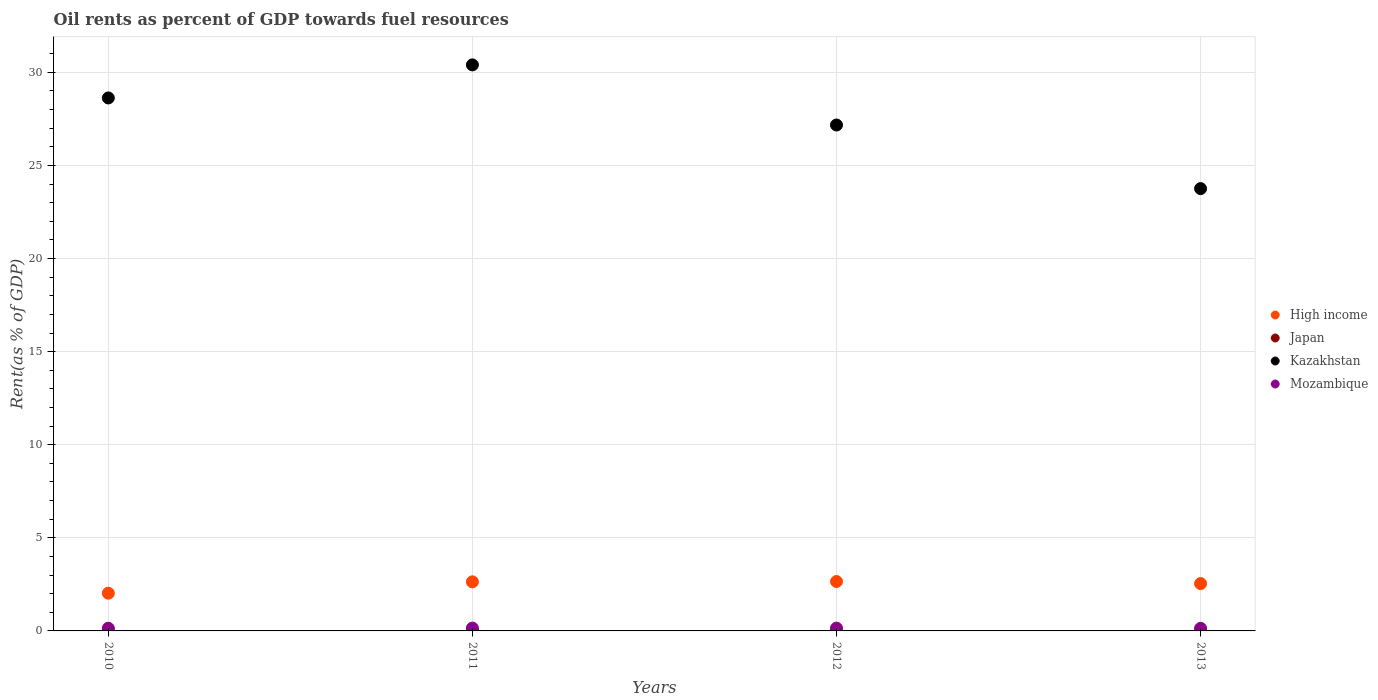Is the number of dotlines equal to the number of legend labels?
Your answer should be compact. Yes. What is the oil rent in Mozambique in 2012?
Keep it short and to the point. 0.15. Across all years, what is the maximum oil rent in Kazakhstan?
Ensure brevity in your answer.  30.4. Across all years, what is the minimum oil rent in High income?
Your response must be concise. 2.03. In which year was the oil rent in Kazakhstan minimum?
Make the answer very short. 2013. What is the total oil rent in Kazakhstan in the graph?
Your response must be concise. 109.96. What is the difference between the oil rent in Japan in 2010 and that in 2012?
Offer a very short reply. -0. What is the difference between the oil rent in High income in 2011 and the oil rent in Japan in 2010?
Your response must be concise. 2.63. What is the average oil rent in Kazakhstan per year?
Provide a succinct answer. 27.49. In the year 2013, what is the difference between the oil rent in Kazakhstan and oil rent in High income?
Your response must be concise. 21.21. In how many years, is the oil rent in Japan greater than 3 %?
Provide a short and direct response. 0. What is the ratio of the oil rent in High income in 2010 to that in 2012?
Ensure brevity in your answer.  0.76. Is the oil rent in Japan in 2011 less than that in 2013?
Give a very brief answer. Yes. Is the difference between the oil rent in Kazakhstan in 2010 and 2011 greater than the difference between the oil rent in High income in 2010 and 2011?
Offer a very short reply. No. What is the difference between the highest and the second highest oil rent in Mozambique?
Ensure brevity in your answer.  0. What is the difference between the highest and the lowest oil rent in High income?
Your answer should be very brief. 0.63. In how many years, is the oil rent in High income greater than the average oil rent in High income taken over all years?
Give a very brief answer. 3. Is it the case that in every year, the sum of the oil rent in Japan and oil rent in Mozambique  is greater than the oil rent in High income?
Keep it short and to the point. No. How many years are there in the graph?
Ensure brevity in your answer.  4. Does the graph contain any zero values?
Provide a short and direct response. No. Does the graph contain grids?
Offer a terse response. Yes. How many legend labels are there?
Your answer should be compact. 4. What is the title of the graph?
Give a very brief answer. Oil rents as percent of GDP towards fuel resources. What is the label or title of the Y-axis?
Offer a very short reply. Rent(as % of GDP). What is the Rent(as % of GDP) of High income in 2010?
Ensure brevity in your answer.  2.03. What is the Rent(as % of GDP) in Japan in 2010?
Keep it short and to the point. 0. What is the Rent(as % of GDP) of Kazakhstan in 2010?
Offer a terse response. 28.63. What is the Rent(as % of GDP) of Mozambique in 2010?
Your answer should be compact. 0.14. What is the Rent(as % of GDP) of High income in 2011?
Offer a terse response. 2.64. What is the Rent(as % of GDP) of Japan in 2011?
Your response must be concise. 0. What is the Rent(as % of GDP) of Kazakhstan in 2011?
Your response must be concise. 30.4. What is the Rent(as % of GDP) of Mozambique in 2011?
Keep it short and to the point. 0.15. What is the Rent(as % of GDP) in High income in 2012?
Provide a short and direct response. 2.65. What is the Rent(as % of GDP) in Japan in 2012?
Provide a short and direct response. 0. What is the Rent(as % of GDP) of Kazakhstan in 2012?
Give a very brief answer. 27.17. What is the Rent(as % of GDP) in Mozambique in 2012?
Make the answer very short. 0.15. What is the Rent(as % of GDP) of High income in 2013?
Keep it short and to the point. 2.54. What is the Rent(as % of GDP) in Japan in 2013?
Your answer should be very brief. 0. What is the Rent(as % of GDP) of Kazakhstan in 2013?
Your answer should be very brief. 23.76. What is the Rent(as % of GDP) in Mozambique in 2013?
Provide a succinct answer. 0.14. Across all years, what is the maximum Rent(as % of GDP) in High income?
Ensure brevity in your answer.  2.65. Across all years, what is the maximum Rent(as % of GDP) of Japan?
Provide a short and direct response. 0. Across all years, what is the maximum Rent(as % of GDP) in Kazakhstan?
Your answer should be very brief. 30.4. Across all years, what is the maximum Rent(as % of GDP) in Mozambique?
Provide a succinct answer. 0.15. Across all years, what is the minimum Rent(as % of GDP) of High income?
Offer a very short reply. 2.03. Across all years, what is the minimum Rent(as % of GDP) of Japan?
Give a very brief answer. 0. Across all years, what is the minimum Rent(as % of GDP) of Kazakhstan?
Keep it short and to the point. 23.76. Across all years, what is the minimum Rent(as % of GDP) of Mozambique?
Make the answer very short. 0.14. What is the total Rent(as % of GDP) in High income in the graph?
Give a very brief answer. 9.86. What is the total Rent(as % of GDP) of Japan in the graph?
Offer a terse response. 0.01. What is the total Rent(as % of GDP) in Kazakhstan in the graph?
Make the answer very short. 109.96. What is the total Rent(as % of GDP) in Mozambique in the graph?
Give a very brief answer. 0.59. What is the difference between the Rent(as % of GDP) in High income in 2010 and that in 2011?
Your response must be concise. -0.61. What is the difference between the Rent(as % of GDP) in Japan in 2010 and that in 2011?
Keep it short and to the point. -0. What is the difference between the Rent(as % of GDP) in Kazakhstan in 2010 and that in 2011?
Ensure brevity in your answer.  -1.78. What is the difference between the Rent(as % of GDP) of Mozambique in 2010 and that in 2011?
Your response must be concise. -0.01. What is the difference between the Rent(as % of GDP) of High income in 2010 and that in 2012?
Provide a short and direct response. -0.63. What is the difference between the Rent(as % of GDP) of Japan in 2010 and that in 2012?
Your answer should be very brief. -0. What is the difference between the Rent(as % of GDP) in Kazakhstan in 2010 and that in 2012?
Give a very brief answer. 1.45. What is the difference between the Rent(as % of GDP) in Mozambique in 2010 and that in 2012?
Give a very brief answer. -0.01. What is the difference between the Rent(as % of GDP) of High income in 2010 and that in 2013?
Keep it short and to the point. -0.52. What is the difference between the Rent(as % of GDP) of Japan in 2010 and that in 2013?
Your answer should be very brief. -0. What is the difference between the Rent(as % of GDP) in Kazakhstan in 2010 and that in 2013?
Your answer should be compact. 4.87. What is the difference between the Rent(as % of GDP) in Mozambique in 2010 and that in 2013?
Your answer should be compact. 0. What is the difference between the Rent(as % of GDP) in High income in 2011 and that in 2012?
Keep it short and to the point. -0.02. What is the difference between the Rent(as % of GDP) of Japan in 2011 and that in 2012?
Offer a terse response. 0. What is the difference between the Rent(as % of GDP) in Kazakhstan in 2011 and that in 2012?
Provide a succinct answer. 3.23. What is the difference between the Rent(as % of GDP) of Mozambique in 2011 and that in 2012?
Offer a very short reply. 0. What is the difference between the Rent(as % of GDP) in High income in 2011 and that in 2013?
Keep it short and to the point. 0.09. What is the difference between the Rent(as % of GDP) of Japan in 2011 and that in 2013?
Give a very brief answer. -0. What is the difference between the Rent(as % of GDP) in Kazakhstan in 2011 and that in 2013?
Keep it short and to the point. 6.65. What is the difference between the Rent(as % of GDP) of Mozambique in 2011 and that in 2013?
Ensure brevity in your answer.  0.01. What is the difference between the Rent(as % of GDP) in High income in 2012 and that in 2013?
Offer a very short reply. 0.11. What is the difference between the Rent(as % of GDP) in Japan in 2012 and that in 2013?
Keep it short and to the point. -0. What is the difference between the Rent(as % of GDP) of Kazakhstan in 2012 and that in 2013?
Keep it short and to the point. 3.42. What is the difference between the Rent(as % of GDP) of Mozambique in 2012 and that in 2013?
Ensure brevity in your answer.  0.01. What is the difference between the Rent(as % of GDP) of High income in 2010 and the Rent(as % of GDP) of Japan in 2011?
Keep it short and to the point. 2.02. What is the difference between the Rent(as % of GDP) in High income in 2010 and the Rent(as % of GDP) in Kazakhstan in 2011?
Give a very brief answer. -28.38. What is the difference between the Rent(as % of GDP) of High income in 2010 and the Rent(as % of GDP) of Mozambique in 2011?
Make the answer very short. 1.87. What is the difference between the Rent(as % of GDP) in Japan in 2010 and the Rent(as % of GDP) in Kazakhstan in 2011?
Keep it short and to the point. -30.4. What is the difference between the Rent(as % of GDP) of Japan in 2010 and the Rent(as % of GDP) of Mozambique in 2011?
Make the answer very short. -0.15. What is the difference between the Rent(as % of GDP) in Kazakhstan in 2010 and the Rent(as % of GDP) in Mozambique in 2011?
Ensure brevity in your answer.  28.47. What is the difference between the Rent(as % of GDP) of High income in 2010 and the Rent(as % of GDP) of Japan in 2012?
Keep it short and to the point. 2.02. What is the difference between the Rent(as % of GDP) in High income in 2010 and the Rent(as % of GDP) in Kazakhstan in 2012?
Give a very brief answer. -25.15. What is the difference between the Rent(as % of GDP) of High income in 2010 and the Rent(as % of GDP) of Mozambique in 2012?
Give a very brief answer. 1.88. What is the difference between the Rent(as % of GDP) in Japan in 2010 and the Rent(as % of GDP) in Kazakhstan in 2012?
Ensure brevity in your answer.  -27.17. What is the difference between the Rent(as % of GDP) in Japan in 2010 and the Rent(as % of GDP) in Mozambique in 2012?
Make the answer very short. -0.15. What is the difference between the Rent(as % of GDP) of Kazakhstan in 2010 and the Rent(as % of GDP) of Mozambique in 2012?
Provide a short and direct response. 28.48. What is the difference between the Rent(as % of GDP) in High income in 2010 and the Rent(as % of GDP) in Japan in 2013?
Keep it short and to the point. 2.02. What is the difference between the Rent(as % of GDP) in High income in 2010 and the Rent(as % of GDP) in Kazakhstan in 2013?
Provide a short and direct response. -21.73. What is the difference between the Rent(as % of GDP) of High income in 2010 and the Rent(as % of GDP) of Mozambique in 2013?
Offer a very short reply. 1.89. What is the difference between the Rent(as % of GDP) of Japan in 2010 and the Rent(as % of GDP) of Kazakhstan in 2013?
Your answer should be compact. -23.75. What is the difference between the Rent(as % of GDP) in Japan in 2010 and the Rent(as % of GDP) in Mozambique in 2013?
Ensure brevity in your answer.  -0.14. What is the difference between the Rent(as % of GDP) of Kazakhstan in 2010 and the Rent(as % of GDP) of Mozambique in 2013?
Ensure brevity in your answer.  28.49. What is the difference between the Rent(as % of GDP) of High income in 2011 and the Rent(as % of GDP) of Japan in 2012?
Your answer should be very brief. 2.63. What is the difference between the Rent(as % of GDP) in High income in 2011 and the Rent(as % of GDP) in Kazakhstan in 2012?
Keep it short and to the point. -24.54. What is the difference between the Rent(as % of GDP) of High income in 2011 and the Rent(as % of GDP) of Mozambique in 2012?
Provide a short and direct response. 2.49. What is the difference between the Rent(as % of GDP) of Japan in 2011 and the Rent(as % of GDP) of Kazakhstan in 2012?
Give a very brief answer. -27.17. What is the difference between the Rent(as % of GDP) in Japan in 2011 and the Rent(as % of GDP) in Mozambique in 2012?
Your response must be concise. -0.15. What is the difference between the Rent(as % of GDP) in Kazakhstan in 2011 and the Rent(as % of GDP) in Mozambique in 2012?
Provide a short and direct response. 30.25. What is the difference between the Rent(as % of GDP) in High income in 2011 and the Rent(as % of GDP) in Japan in 2013?
Keep it short and to the point. 2.63. What is the difference between the Rent(as % of GDP) of High income in 2011 and the Rent(as % of GDP) of Kazakhstan in 2013?
Your answer should be very brief. -21.12. What is the difference between the Rent(as % of GDP) in High income in 2011 and the Rent(as % of GDP) in Mozambique in 2013?
Provide a succinct answer. 2.5. What is the difference between the Rent(as % of GDP) in Japan in 2011 and the Rent(as % of GDP) in Kazakhstan in 2013?
Your response must be concise. -23.75. What is the difference between the Rent(as % of GDP) in Japan in 2011 and the Rent(as % of GDP) in Mozambique in 2013?
Provide a succinct answer. -0.14. What is the difference between the Rent(as % of GDP) of Kazakhstan in 2011 and the Rent(as % of GDP) of Mozambique in 2013?
Give a very brief answer. 30.26. What is the difference between the Rent(as % of GDP) of High income in 2012 and the Rent(as % of GDP) of Japan in 2013?
Ensure brevity in your answer.  2.65. What is the difference between the Rent(as % of GDP) in High income in 2012 and the Rent(as % of GDP) in Kazakhstan in 2013?
Provide a short and direct response. -21.1. What is the difference between the Rent(as % of GDP) in High income in 2012 and the Rent(as % of GDP) in Mozambique in 2013?
Your answer should be very brief. 2.51. What is the difference between the Rent(as % of GDP) of Japan in 2012 and the Rent(as % of GDP) of Kazakhstan in 2013?
Offer a terse response. -23.75. What is the difference between the Rent(as % of GDP) of Japan in 2012 and the Rent(as % of GDP) of Mozambique in 2013?
Offer a terse response. -0.14. What is the difference between the Rent(as % of GDP) in Kazakhstan in 2012 and the Rent(as % of GDP) in Mozambique in 2013?
Your answer should be very brief. 27.03. What is the average Rent(as % of GDP) of High income per year?
Your answer should be compact. 2.46. What is the average Rent(as % of GDP) in Japan per year?
Ensure brevity in your answer.  0. What is the average Rent(as % of GDP) in Kazakhstan per year?
Make the answer very short. 27.49. What is the average Rent(as % of GDP) in Mozambique per year?
Your answer should be very brief. 0.15. In the year 2010, what is the difference between the Rent(as % of GDP) in High income and Rent(as % of GDP) in Japan?
Provide a succinct answer. 2.02. In the year 2010, what is the difference between the Rent(as % of GDP) in High income and Rent(as % of GDP) in Kazakhstan?
Your response must be concise. -26.6. In the year 2010, what is the difference between the Rent(as % of GDP) of High income and Rent(as % of GDP) of Mozambique?
Make the answer very short. 1.88. In the year 2010, what is the difference between the Rent(as % of GDP) in Japan and Rent(as % of GDP) in Kazakhstan?
Your answer should be very brief. -28.62. In the year 2010, what is the difference between the Rent(as % of GDP) in Japan and Rent(as % of GDP) in Mozambique?
Your answer should be compact. -0.14. In the year 2010, what is the difference between the Rent(as % of GDP) in Kazakhstan and Rent(as % of GDP) in Mozambique?
Provide a succinct answer. 28.48. In the year 2011, what is the difference between the Rent(as % of GDP) in High income and Rent(as % of GDP) in Japan?
Ensure brevity in your answer.  2.63. In the year 2011, what is the difference between the Rent(as % of GDP) in High income and Rent(as % of GDP) in Kazakhstan?
Offer a very short reply. -27.77. In the year 2011, what is the difference between the Rent(as % of GDP) of High income and Rent(as % of GDP) of Mozambique?
Your answer should be compact. 2.48. In the year 2011, what is the difference between the Rent(as % of GDP) of Japan and Rent(as % of GDP) of Kazakhstan?
Make the answer very short. -30.4. In the year 2011, what is the difference between the Rent(as % of GDP) in Japan and Rent(as % of GDP) in Mozambique?
Make the answer very short. -0.15. In the year 2011, what is the difference between the Rent(as % of GDP) of Kazakhstan and Rent(as % of GDP) of Mozambique?
Provide a succinct answer. 30.25. In the year 2012, what is the difference between the Rent(as % of GDP) of High income and Rent(as % of GDP) of Japan?
Provide a succinct answer. 2.65. In the year 2012, what is the difference between the Rent(as % of GDP) in High income and Rent(as % of GDP) in Kazakhstan?
Provide a succinct answer. -24.52. In the year 2012, what is the difference between the Rent(as % of GDP) in High income and Rent(as % of GDP) in Mozambique?
Your answer should be very brief. 2.5. In the year 2012, what is the difference between the Rent(as % of GDP) in Japan and Rent(as % of GDP) in Kazakhstan?
Offer a very short reply. -27.17. In the year 2012, what is the difference between the Rent(as % of GDP) of Japan and Rent(as % of GDP) of Mozambique?
Your answer should be compact. -0.15. In the year 2012, what is the difference between the Rent(as % of GDP) in Kazakhstan and Rent(as % of GDP) in Mozambique?
Ensure brevity in your answer.  27.02. In the year 2013, what is the difference between the Rent(as % of GDP) in High income and Rent(as % of GDP) in Japan?
Keep it short and to the point. 2.54. In the year 2013, what is the difference between the Rent(as % of GDP) in High income and Rent(as % of GDP) in Kazakhstan?
Give a very brief answer. -21.21. In the year 2013, what is the difference between the Rent(as % of GDP) in High income and Rent(as % of GDP) in Mozambique?
Provide a succinct answer. 2.4. In the year 2013, what is the difference between the Rent(as % of GDP) in Japan and Rent(as % of GDP) in Kazakhstan?
Your answer should be compact. -23.75. In the year 2013, what is the difference between the Rent(as % of GDP) of Japan and Rent(as % of GDP) of Mozambique?
Ensure brevity in your answer.  -0.14. In the year 2013, what is the difference between the Rent(as % of GDP) in Kazakhstan and Rent(as % of GDP) in Mozambique?
Keep it short and to the point. 23.62. What is the ratio of the Rent(as % of GDP) of High income in 2010 to that in 2011?
Offer a terse response. 0.77. What is the ratio of the Rent(as % of GDP) in Japan in 2010 to that in 2011?
Offer a terse response. 0.83. What is the ratio of the Rent(as % of GDP) of Kazakhstan in 2010 to that in 2011?
Keep it short and to the point. 0.94. What is the ratio of the Rent(as % of GDP) in Mozambique in 2010 to that in 2011?
Provide a succinct answer. 0.94. What is the ratio of the Rent(as % of GDP) of High income in 2010 to that in 2012?
Your answer should be very brief. 0.76. What is the ratio of the Rent(as % of GDP) of Japan in 2010 to that in 2012?
Your answer should be very brief. 0.86. What is the ratio of the Rent(as % of GDP) in Kazakhstan in 2010 to that in 2012?
Your answer should be compact. 1.05. What is the ratio of the Rent(as % of GDP) in Mozambique in 2010 to that in 2012?
Ensure brevity in your answer.  0.96. What is the ratio of the Rent(as % of GDP) in High income in 2010 to that in 2013?
Keep it short and to the point. 0.8. What is the ratio of the Rent(as % of GDP) of Japan in 2010 to that in 2013?
Ensure brevity in your answer.  0.78. What is the ratio of the Rent(as % of GDP) of Kazakhstan in 2010 to that in 2013?
Your response must be concise. 1.21. What is the ratio of the Rent(as % of GDP) in Mozambique in 2010 to that in 2013?
Your response must be concise. 1.03. What is the ratio of the Rent(as % of GDP) of Japan in 2011 to that in 2012?
Provide a succinct answer. 1.04. What is the ratio of the Rent(as % of GDP) in Kazakhstan in 2011 to that in 2012?
Your answer should be very brief. 1.12. What is the ratio of the Rent(as % of GDP) of Mozambique in 2011 to that in 2012?
Provide a short and direct response. 1.02. What is the ratio of the Rent(as % of GDP) in High income in 2011 to that in 2013?
Give a very brief answer. 1.04. What is the ratio of the Rent(as % of GDP) of Japan in 2011 to that in 2013?
Make the answer very short. 0.94. What is the ratio of the Rent(as % of GDP) in Kazakhstan in 2011 to that in 2013?
Offer a very short reply. 1.28. What is the ratio of the Rent(as % of GDP) of Mozambique in 2011 to that in 2013?
Offer a very short reply. 1.09. What is the ratio of the Rent(as % of GDP) of High income in 2012 to that in 2013?
Your answer should be compact. 1.04. What is the ratio of the Rent(as % of GDP) of Japan in 2012 to that in 2013?
Give a very brief answer. 0.91. What is the ratio of the Rent(as % of GDP) of Kazakhstan in 2012 to that in 2013?
Your response must be concise. 1.14. What is the ratio of the Rent(as % of GDP) of Mozambique in 2012 to that in 2013?
Provide a short and direct response. 1.07. What is the difference between the highest and the second highest Rent(as % of GDP) in High income?
Your response must be concise. 0.02. What is the difference between the highest and the second highest Rent(as % of GDP) of Kazakhstan?
Offer a very short reply. 1.78. What is the difference between the highest and the second highest Rent(as % of GDP) of Mozambique?
Your answer should be compact. 0. What is the difference between the highest and the lowest Rent(as % of GDP) of High income?
Your response must be concise. 0.63. What is the difference between the highest and the lowest Rent(as % of GDP) of Japan?
Offer a terse response. 0. What is the difference between the highest and the lowest Rent(as % of GDP) in Kazakhstan?
Give a very brief answer. 6.65. What is the difference between the highest and the lowest Rent(as % of GDP) of Mozambique?
Your response must be concise. 0.01. 